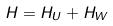Convert formula to latex. <formula><loc_0><loc_0><loc_500><loc_500>H = H _ { U } + H _ { W }</formula> 